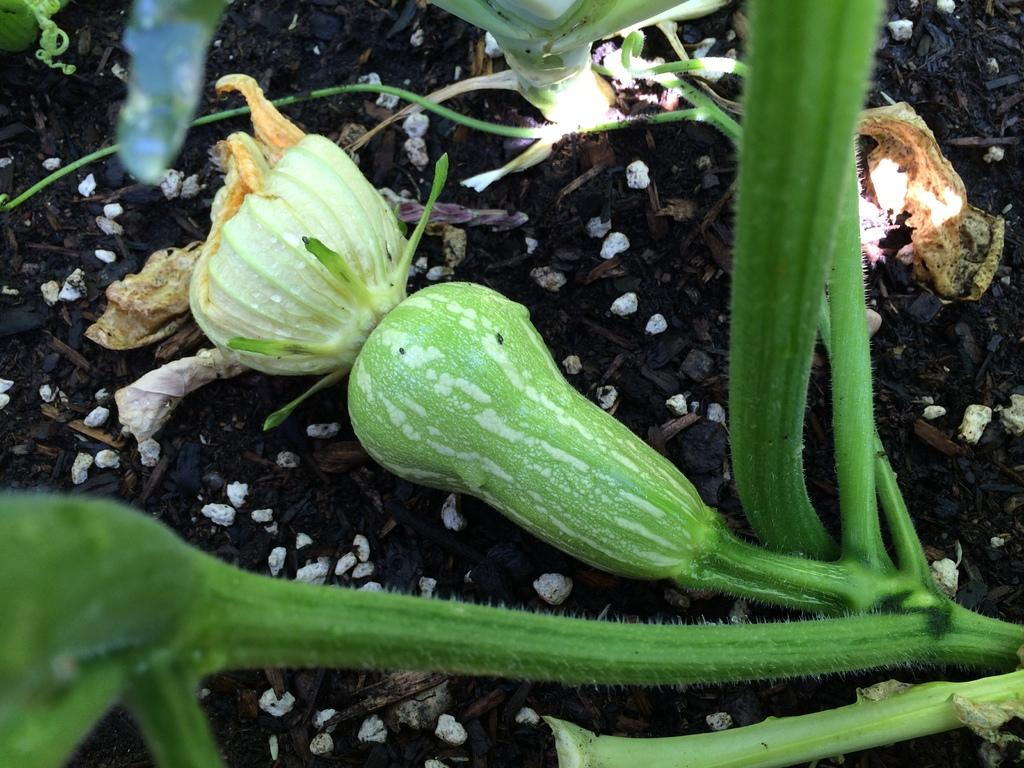What is located on the ground in the image? There is a vegetable on the ground in the image. What type of worm can be seen crawling on the vegetable in the image? There is no worm present in the image; it only features a vegetable on the ground. 